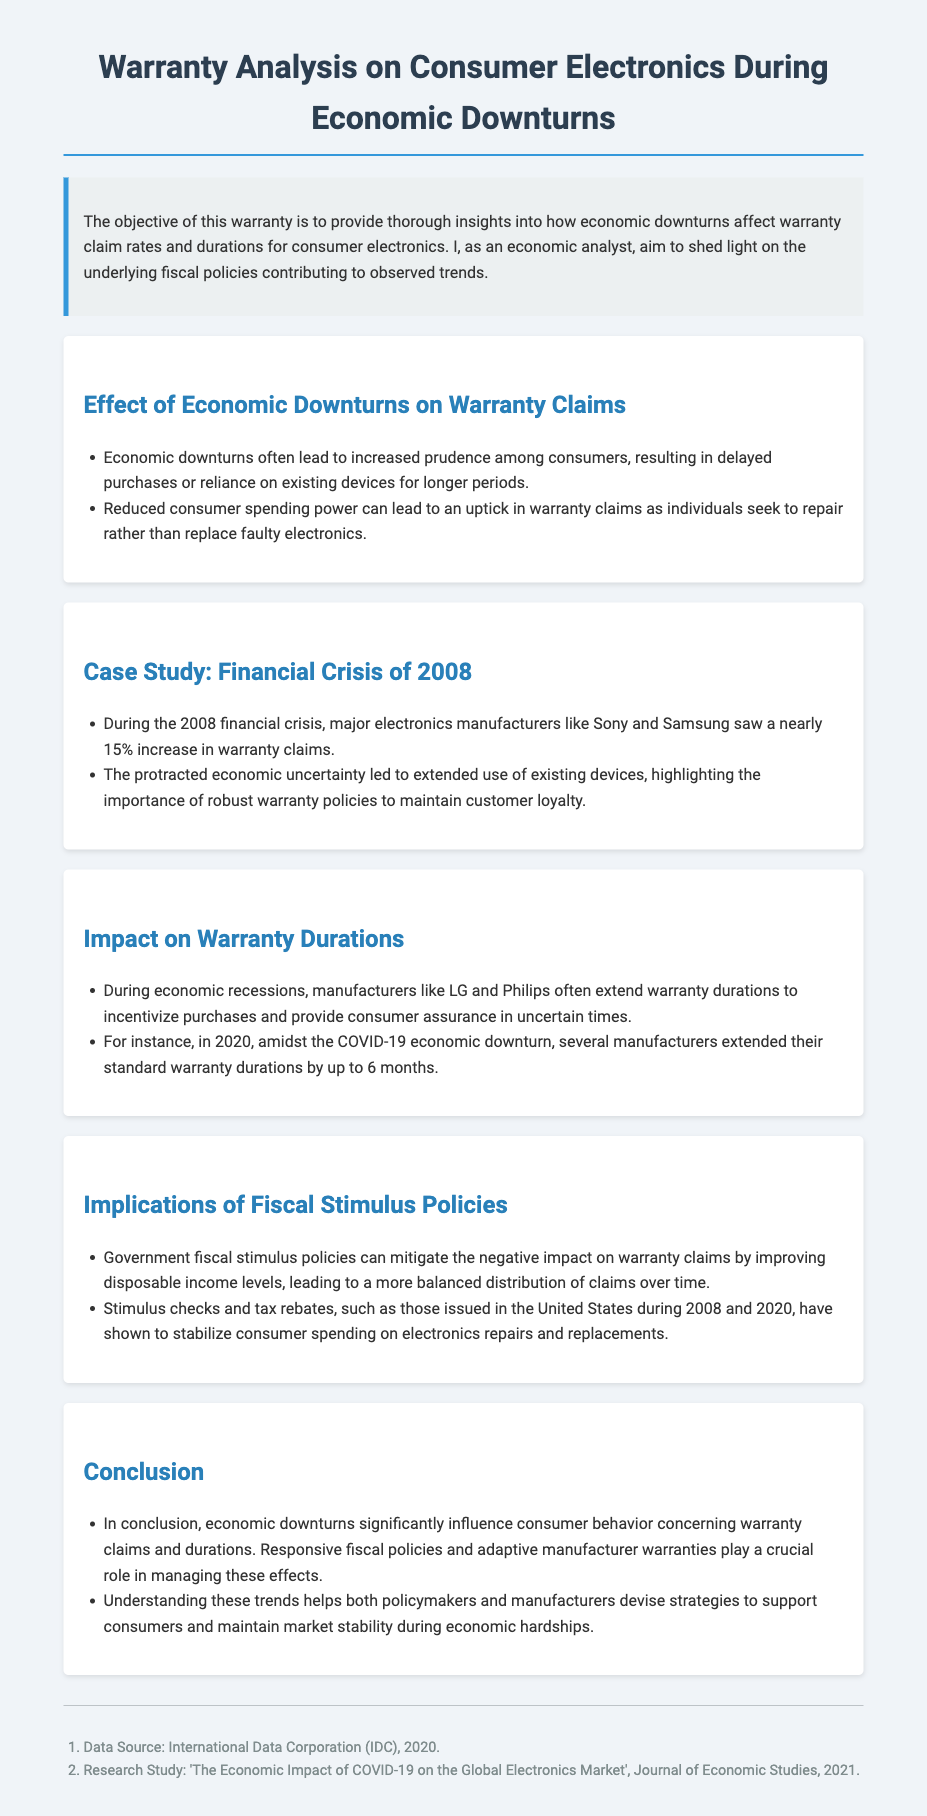What was the increase in warranty claims during the 2008 financial crisis? The document states that major electronics manufacturers saw a nearly 15% increase in warranty claims during the 2008 financial crisis.
Answer: 15% What year was the COVID-19 economic downturn? The document mentions that the COVID-19 economic downturn occurred in 2020.
Answer: 2020 Which companies extended warranty durations during economic recessions? The document indicates that manufacturers like LG and Philips often extend warranty durations during economic recessions.
Answer: LG and Philips What fiscal measures were mentioned as helping to stabilize warranty claims? The document refers to stimulus checks and tax rebates as fiscal measures that help stabilize warranty claims.
Answer: Stimulus checks and tax rebates What impact do economic downturns have on consumer behavior regarding warranty claims? It is stated that economic downturns significantly influence consumer behavior, leading to an increased reliance on warranty claims during such periods.
Answer: Increased reliance on warranty claims What year did several manufacturers extend their standard warranty durations by up to 6 months? The document notes that in 2020, several manufacturers extended their standard warranty durations by up to 6 months.
Answer: 2020 Which two crises did the document reference in relation to warranty claims? The document referenced the financial crisis of 2008 and the COVID-19 economic downturn of 2020 in relation to warranty claims.
Answer: 2008 and 2020 What do the government fiscal stimulus policies aim to influence according to the document? Government fiscal stimulus policies can mitigate the negative impact on warranty claims by improving disposable income levels.
Answer: Warranty claims 